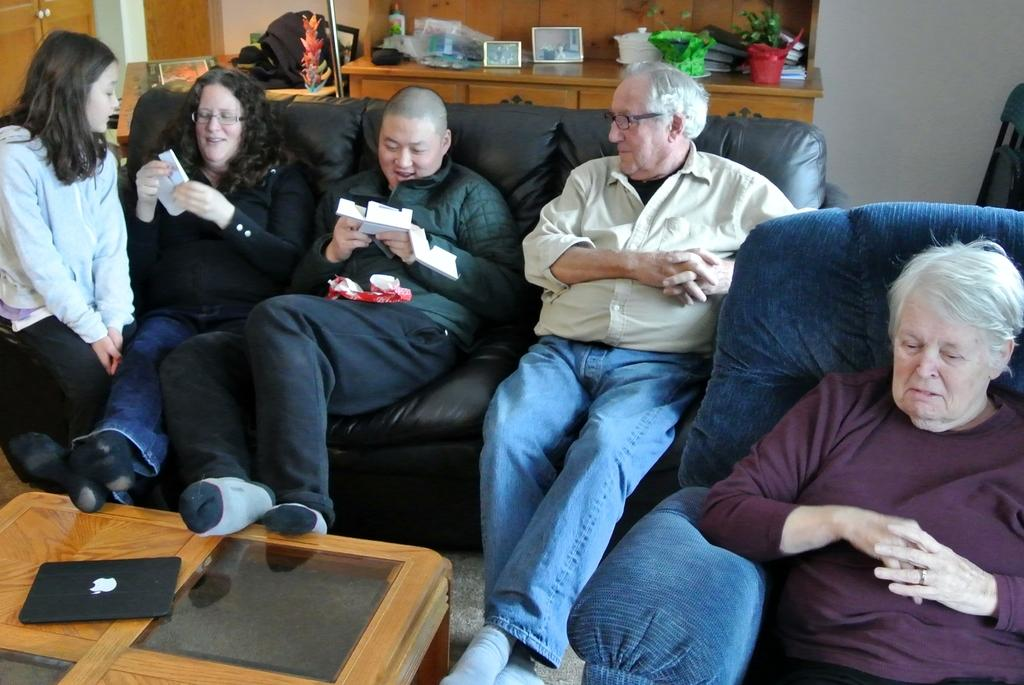What are the people in the image doing? The group of people is sitting on a sofa. What is in front of the people sitting on the sofa? There is another sofa in front of them. What electronic device can be seen on the front sofa? A MacBook is present on the front sofa. What type of bird is sitting on the MacBook in the image? There is no bird, specifically a robin, present on the MacBook in the image. 